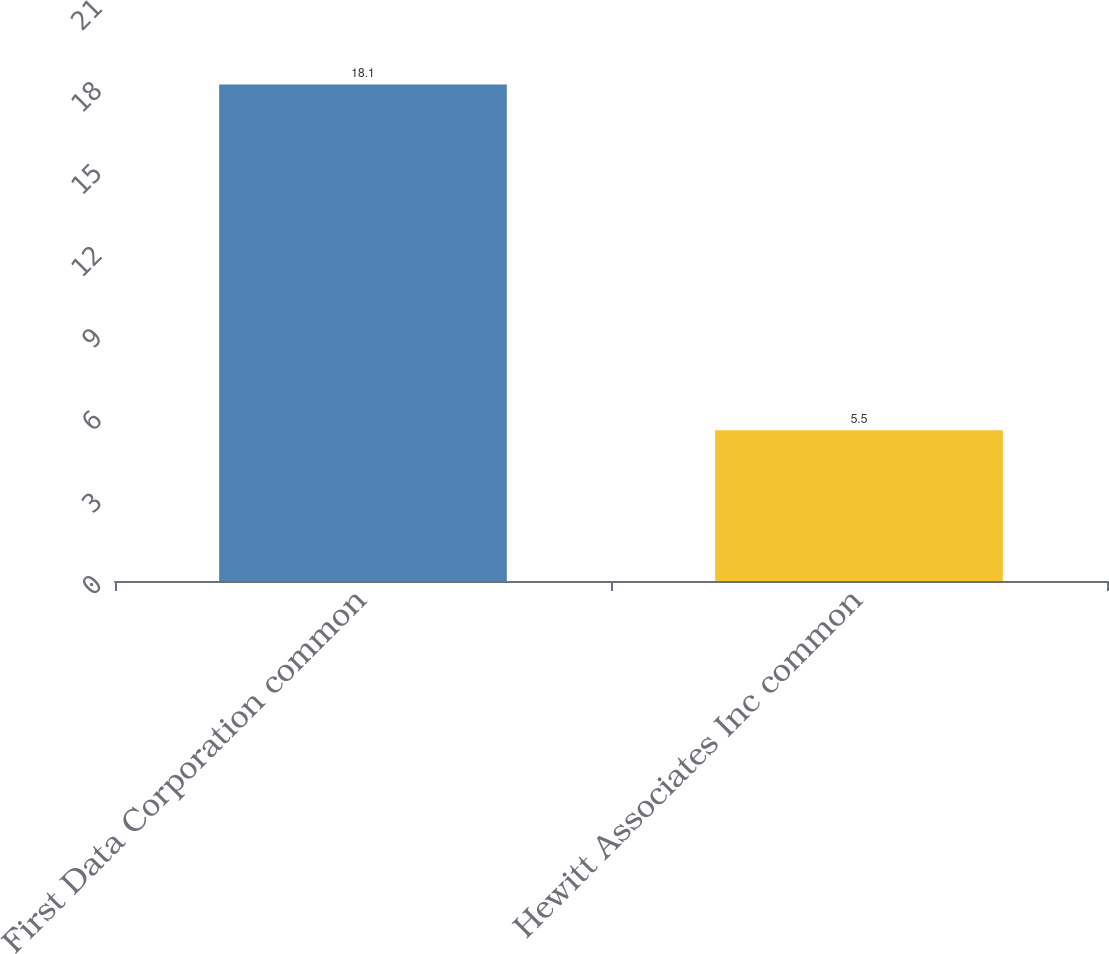Convert chart. <chart><loc_0><loc_0><loc_500><loc_500><bar_chart><fcel>First Data Corporation common<fcel>Hewitt Associates Inc common<nl><fcel>18.1<fcel>5.5<nl></chart> 